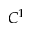Convert formula to latex. <formula><loc_0><loc_0><loc_500><loc_500>C ^ { 1 }</formula> 